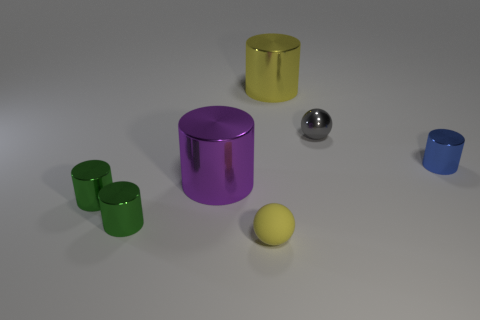How many objects are there in total? There are six objects in total: three green cylinders, two cylinders (one purple and one yellow), and one small silver sphere.  Can you describe the texture of the objects? The spheres and the yellow cylinder have a smooth and reflective surface, suggesting they might be metallic, while the green cylinders and the purple cylinder seem to have a matte finish, indicating they might be made of rubber or plastic. 